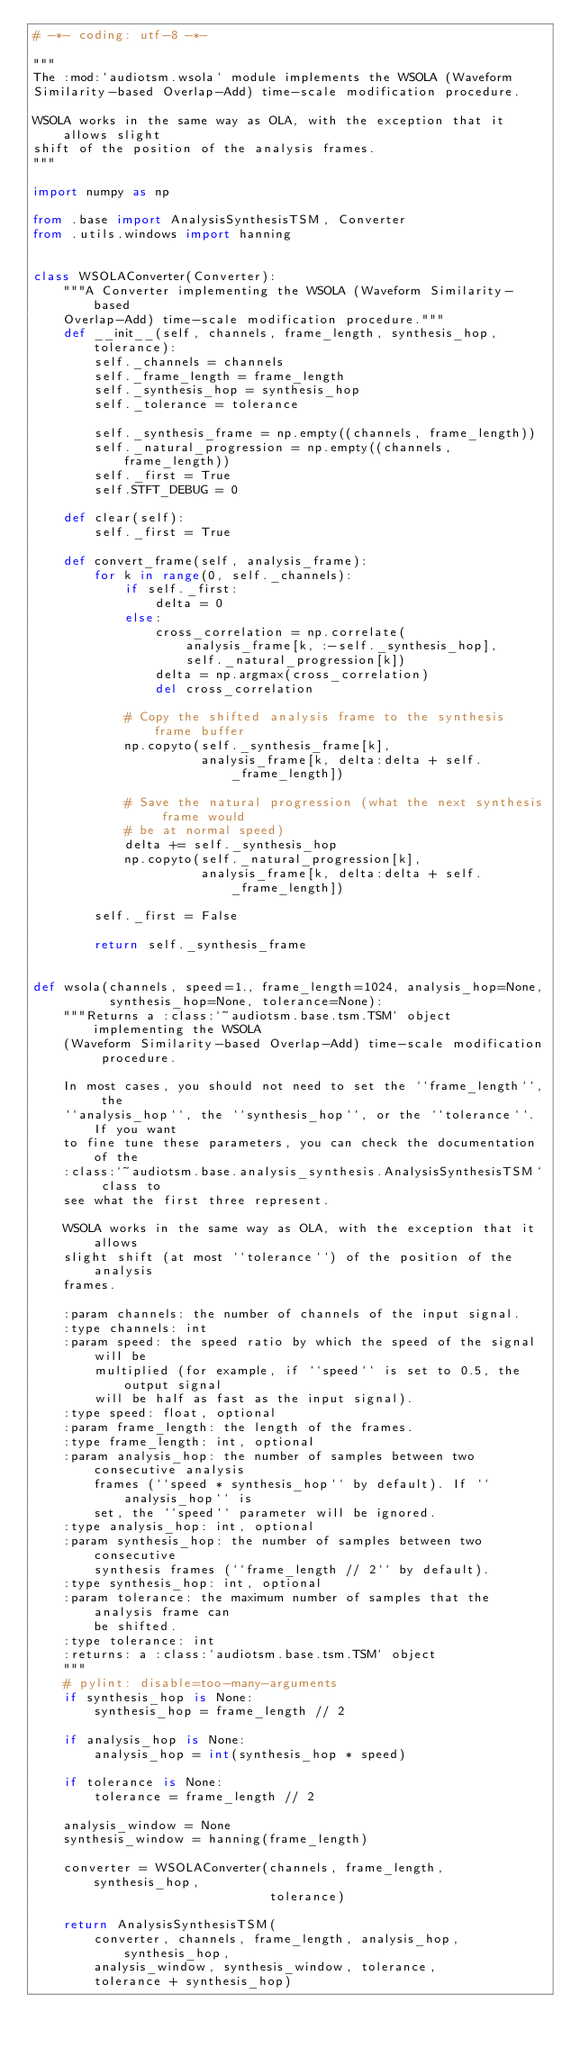<code> <loc_0><loc_0><loc_500><loc_500><_Python_># -*- coding: utf-8 -*-

"""
The :mod:`audiotsm.wsola` module implements the WSOLA (Waveform
Similarity-based Overlap-Add) time-scale modification procedure.

WSOLA works in the same way as OLA, with the exception that it allows slight
shift of the position of the analysis frames.
"""

import numpy as np

from .base import AnalysisSynthesisTSM, Converter
from .utils.windows import hanning


class WSOLAConverter(Converter):
    """A Converter implementing the WSOLA (Waveform Similarity-based
    Overlap-Add) time-scale modification procedure."""
    def __init__(self, channels, frame_length, synthesis_hop, tolerance):
        self._channels = channels
        self._frame_length = frame_length
        self._synthesis_hop = synthesis_hop
        self._tolerance = tolerance

        self._synthesis_frame = np.empty((channels, frame_length))
        self._natural_progression = np.empty((channels, frame_length))
        self._first = True
        self.STFT_DEBUG = 0

    def clear(self):
        self._first = True

    def convert_frame(self, analysis_frame):
        for k in range(0, self._channels):
            if self._first:
                delta = 0
            else:
                cross_correlation = np.correlate(
                    analysis_frame[k, :-self._synthesis_hop],
                    self._natural_progression[k])
                delta = np.argmax(cross_correlation)
                del cross_correlation

            # Copy the shifted analysis frame to the synthesis frame buffer
            np.copyto(self._synthesis_frame[k],
                      analysis_frame[k, delta:delta + self._frame_length])

            # Save the natural progression (what the next synthesis frame would
            # be at normal speed)
            delta += self._synthesis_hop
            np.copyto(self._natural_progression[k],
                      analysis_frame[k, delta:delta + self._frame_length])

        self._first = False

        return self._synthesis_frame


def wsola(channels, speed=1., frame_length=1024, analysis_hop=None,
          synthesis_hop=None, tolerance=None):
    """Returns a :class:`~audiotsm.base.tsm.TSM` object implementing the WSOLA
    (Waveform Similarity-based Overlap-Add) time-scale modification procedure.

    In most cases, you should not need to set the ``frame_length``, the
    ``analysis_hop``, the ``synthesis_hop``, or the ``tolerance``. If you want
    to fine tune these parameters, you can check the documentation of the
    :class:`~audiotsm.base.analysis_synthesis.AnalysisSynthesisTSM` class to
    see what the first three represent.

    WSOLA works in the same way as OLA, with the exception that it allows
    slight shift (at most ``tolerance``) of the position of the analysis
    frames.

    :param channels: the number of channels of the input signal.
    :type channels: int
    :param speed: the speed ratio by which the speed of the signal will be
        multiplied (for example, if ``speed`` is set to 0.5, the output signal
        will be half as fast as the input signal).
    :type speed: float, optional
    :param frame_length: the length of the frames.
    :type frame_length: int, optional
    :param analysis_hop: the number of samples between two consecutive analysis
        frames (``speed * synthesis_hop`` by default). If ``analysis_hop`` is
        set, the ``speed`` parameter will be ignored.
    :type analysis_hop: int, optional
    :param synthesis_hop: the number of samples between two consecutive
        synthesis frames (``frame_length // 2`` by default).
    :type synthesis_hop: int, optional
    :param tolerance: the maximum number of samples that the analysis frame can
        be shifted.
    :type tolerance: int
    :returns: a :class:`audiotsm.base.tsm.TSM` object
    """
    # pylint: disable=too-many-arguments
    if synthesis_hop is None:
        synthesis_hop = frame_length // 2

    if analysis_hop is None:
        analysis_hop = int(synthesis_hop * speed)

    if tolerance is None:
        tolerance = frame_length // 2

    analysis_window = None
    synthesis_window = hanning(frame_length)

    converter = WSOLAConverter(channels, frame_length, synthesis_hop,
                               tolerance)

    return AnalysisSynthesisTSM(
        converter, channels, frame_length, analysis_hop, synthesis_hop,
        analysis_window, synthesis_window, tolerance,
        tolerance + synthesis_hop)
</code> 